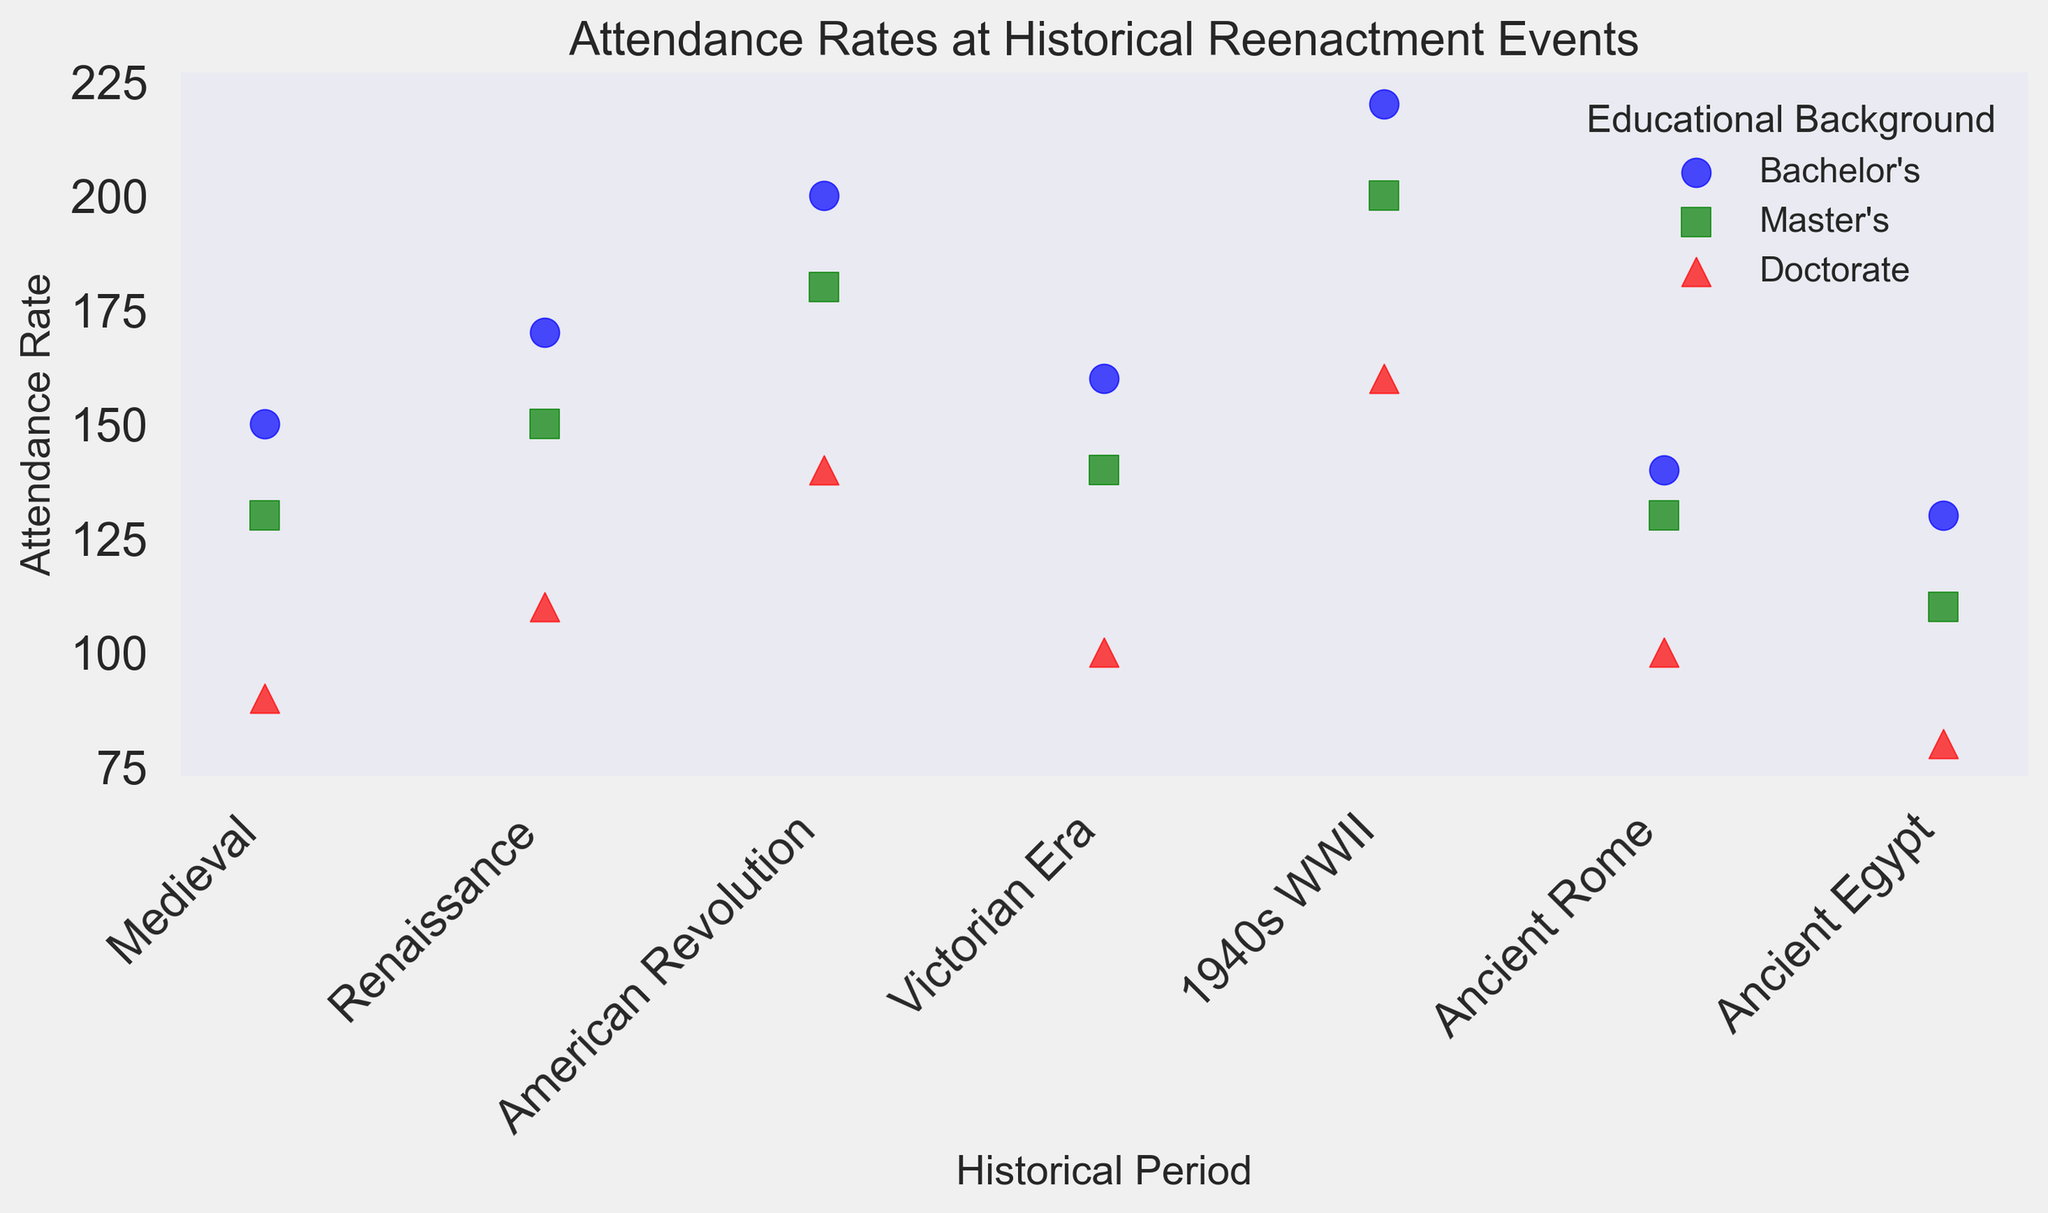What's the historical period with the highest attendance rate for attendees with a Bachelor's degree? The figure showcases the attendance rates differentiated by historical period and educational background. Looking at the plot, the point with the highest value on the y-axis for Bachelor's degree (blue circles) is in the "1940s WWII" period with an attendance rate of 220.
Answer: 1940s WWII What's the difference in attendance rates between Bachelor's and Doctorate attendees for the American Revolution period? Observe the points for the American Revolution period. The attendance rate for Bachelor's is 200 and for Doctorate is 140. The difference is calculated as 200 - 140.
Answer: 60 Which educational background has the smallest range of attendance rates across all historical periods? Calculate the range of attendance rates for each educational background by finding the difference between the highest and lowest attendance rates in each set. Bachelor's range: 220-130=90, Master's range: 200-110=90, Doctorate's range: 160-80=80.
Answer: Doctorate How does the attendance rate for Master’s attendees in the Victorian Era compare to those in the Renaissance? Compare the y-values for the Master's level in both periods. The Victorian Era has 140 and the Renaissance has 150. 140 is less than 150.
Answer: Less What is the average attendance rate for Doctorate attendees? Find the y-values for Doctorate attendees across all periods and calculate the average: (90 + 110 + 140 + 100 + 160 + 100 + 80)/7 = (780/7) = 111.43.
Answer: 111.43 Which educational level has a consistent decline in attendance rates from Medieval to 1940s WWII? Examine the y-values in the Medieval to 1940s period for each educational background. The Doctorate level shows a consistent decline in attendance rates: Medieval (90), Renaissance (110), American Revolution (140), Victorian Era (100), 1940s WWII (160).
Answer: None For the historical period of Ancient Egypt, which educational background has the highest attendance rate? Locate the Ancient Egypt period on the x-axis and compare the y-values. Bachelor's rate is 130, Master's is 110, and Doctorate is 80. Bachelor's has the highest rate.
Answer: Bachelor's What is the median attendance rate for Master’s attendees? List all attendance rates for Master's: 130, 150, 180, 140, 200, 130, 110. Arrange in ascending order: 110, 130, 130, 140, 150, 180, 200. The median value is the middle value in this ordered list, which is 140.
Answer: 140 